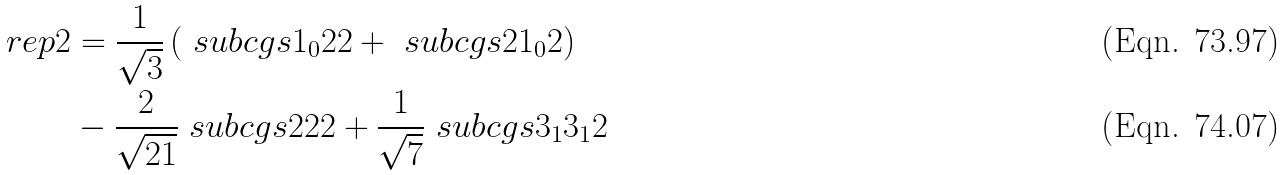<formula> <loc_0><loc_0><loc_500><loc_500>\ r e p { 2 } & = \frac { 1 } { \sqrt { 3 } } \left ( \ s u b c g s { 1 _ { 0 } } { 2 } { 2 } + \ s u b c g s { 2 } { 1 _ { 0 } } { 2 } \right ) \\ & - \frac { 2 } { \sqrt { 2 1 } } \ s u b c g s { 2 } { 2 } { 2 } + \frac { 1 } { \sqrt { 7 } } \ s u b c g s { 3 _ { 1 } } { 3 _ { 1 } } { 2 }</formula> 